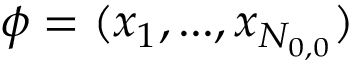Convert formula to latex. <formula><loc_0><loc_0><loc_500><loc_500>\phi = ( x _ { 1 } , \dots , x _ { N _ { 0 , 0 } } )</formula> 